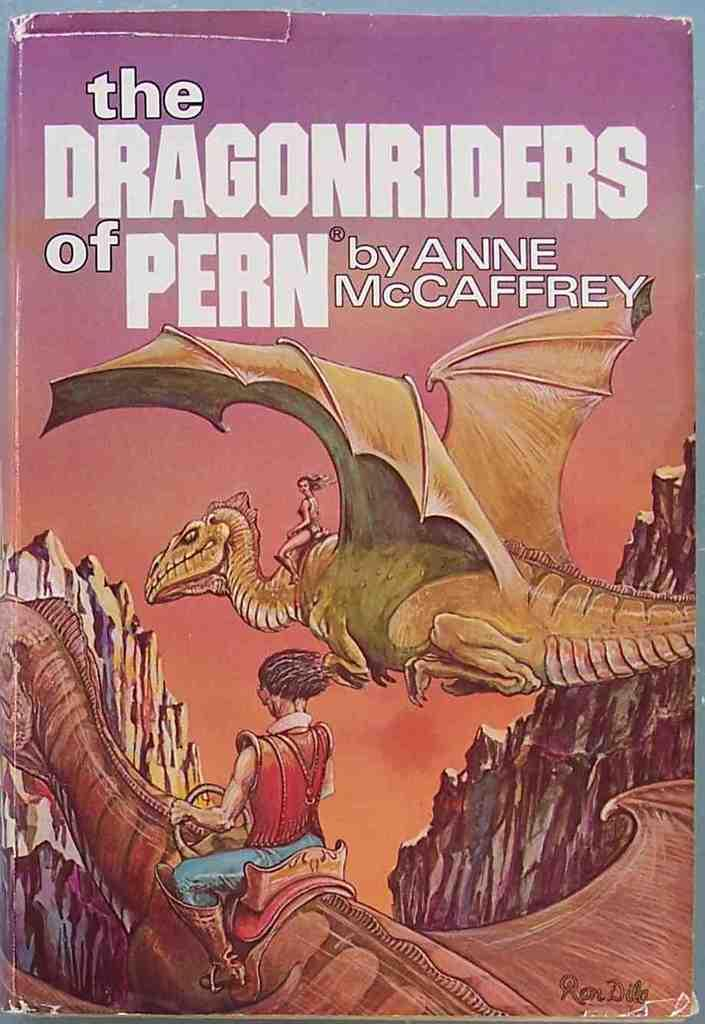<image>
Provide a brief description of the given image. The Dragonriders of Pern was written by Anne McCaffrey. 